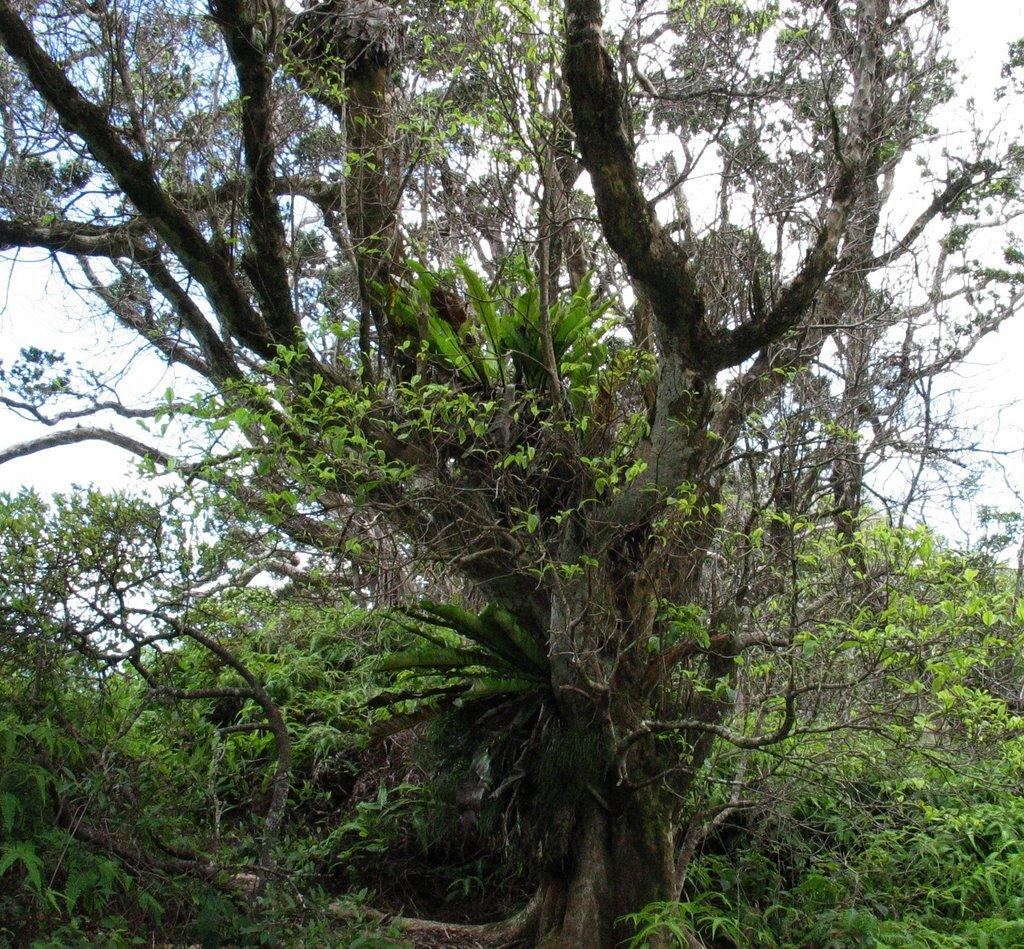What is the main subject in the center of the image? There are trees in the center of the image. What size is the wrench used to adjust the bedroom furniture in the image? There is no wrench or bedroom furniture present in the image; it only features trees in the center. 